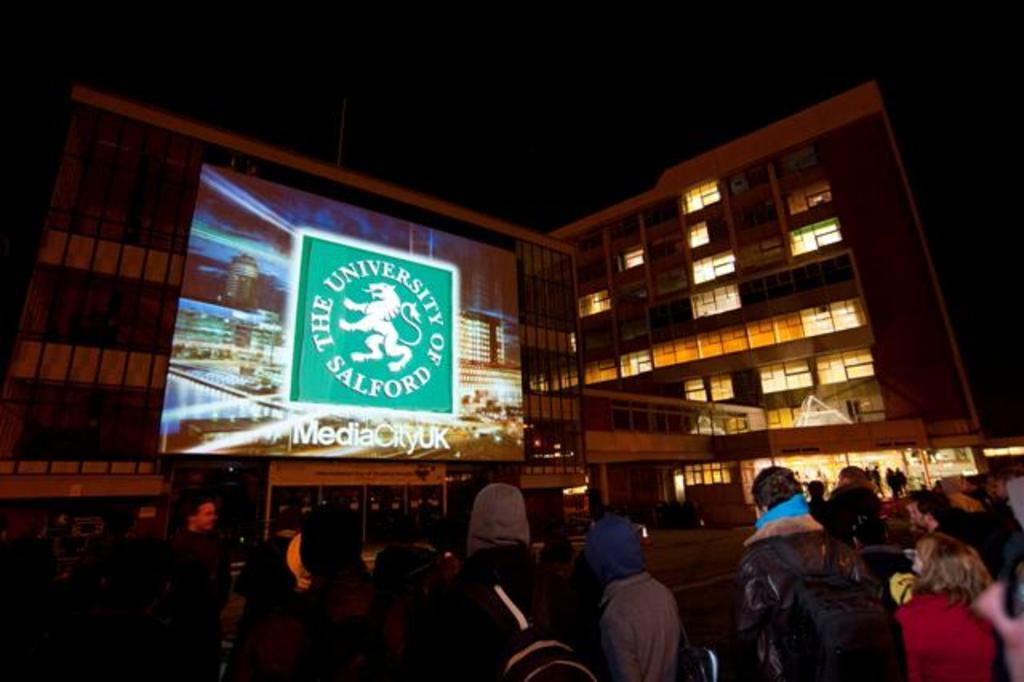How many people are in the image? There are few persons in the image. What can be seen in the background of the image? There are buildings in the background of the image. What is the object visible in the image that displays information or images? There is a screen visible in the image. What type of surface can be seen at the bottom of the image? There is a road at the bottom of the image. What type of nail can be seen in the image? There is no nail present in the image. Can you describe the coastline visible in the image? There is no coastline visible in the image; it features a road and buildings. 